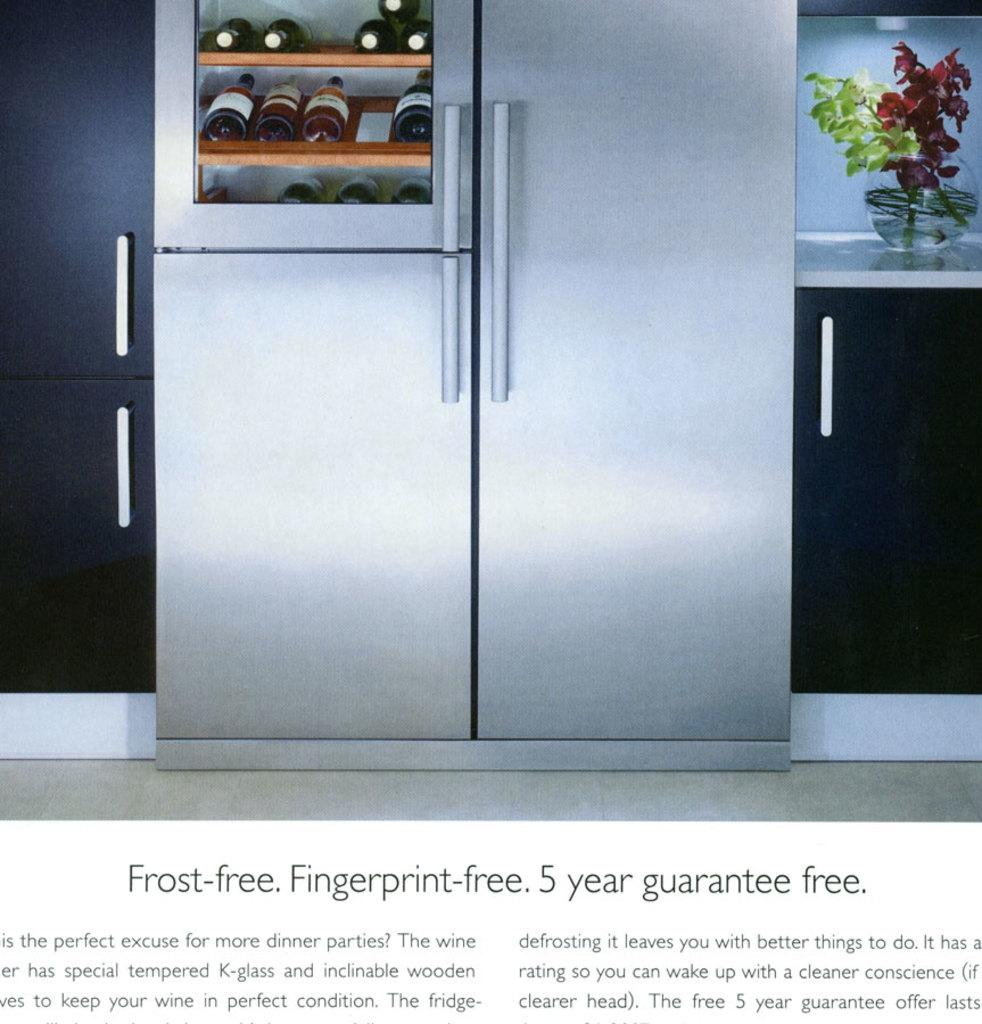<image>
Relay a brief, clear account of the picture shown. A large fridge which guarantees that it is frost free and  fingerprint-free. 